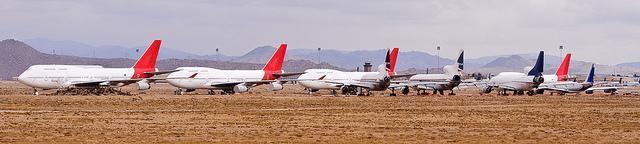How many airplanes are there?
Give a very brief answer. 2. How many elephants are in the picture?
Give a very brief answer. 0. 